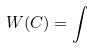<formula> <loc_0><loc_0><loc_500><loc_500>W ( C ) = \int</formula> 